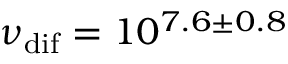<formula> <loc_0><loc_0><loc_500><loc_500>\nu _ { d i f } = 1 0 ^ { 7 . 6 \pm 0 . 8 }</formula> 